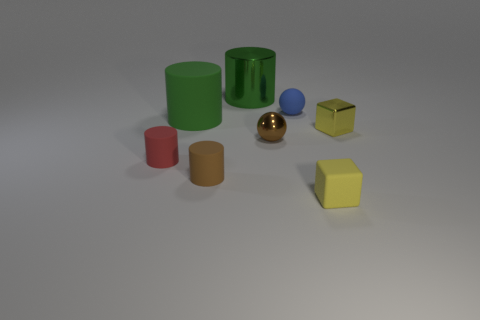How many matte things are in front of the small shiny sphere and behind the yellow matte object?
Your answer should be compact. 2. What is the shape of the yellow matte thing that is the same size as the blue rubber ball?
Keep it short and to the point. Cube. There is a green rubber cylinder on the left side of the cube that is in front of the small red thing; are there any yellow things on the right side of it?
Offer a very short reply. Yes. There is a tiny metal ball; is it the same color as the small cube that is in front of the small brown shiny thing?
Your response must be concise. No. How many large matte objects are the same color as the large metal thing?
Give a very brief answer. 1. What size is the green matte object that is left of the tiny shiny thing that is to the right of the tiny yellow matte block?
Your answer should be very brief. Large. What number of things are either tiny objects that are behind the tiny yellow rubber object or gray shiny cylinders?
Your answer should be very brief. 5. Is there a green thing that has the same size as the red matte cylinder?
Make the answer very short. No. There is a big cylinder that is behind the blue matte object; are there any small objects that are to the left of it?
Make the answer very short. Yes. What number of cylinders are blue matte things or large green things?
Make the answer very short. 2. 